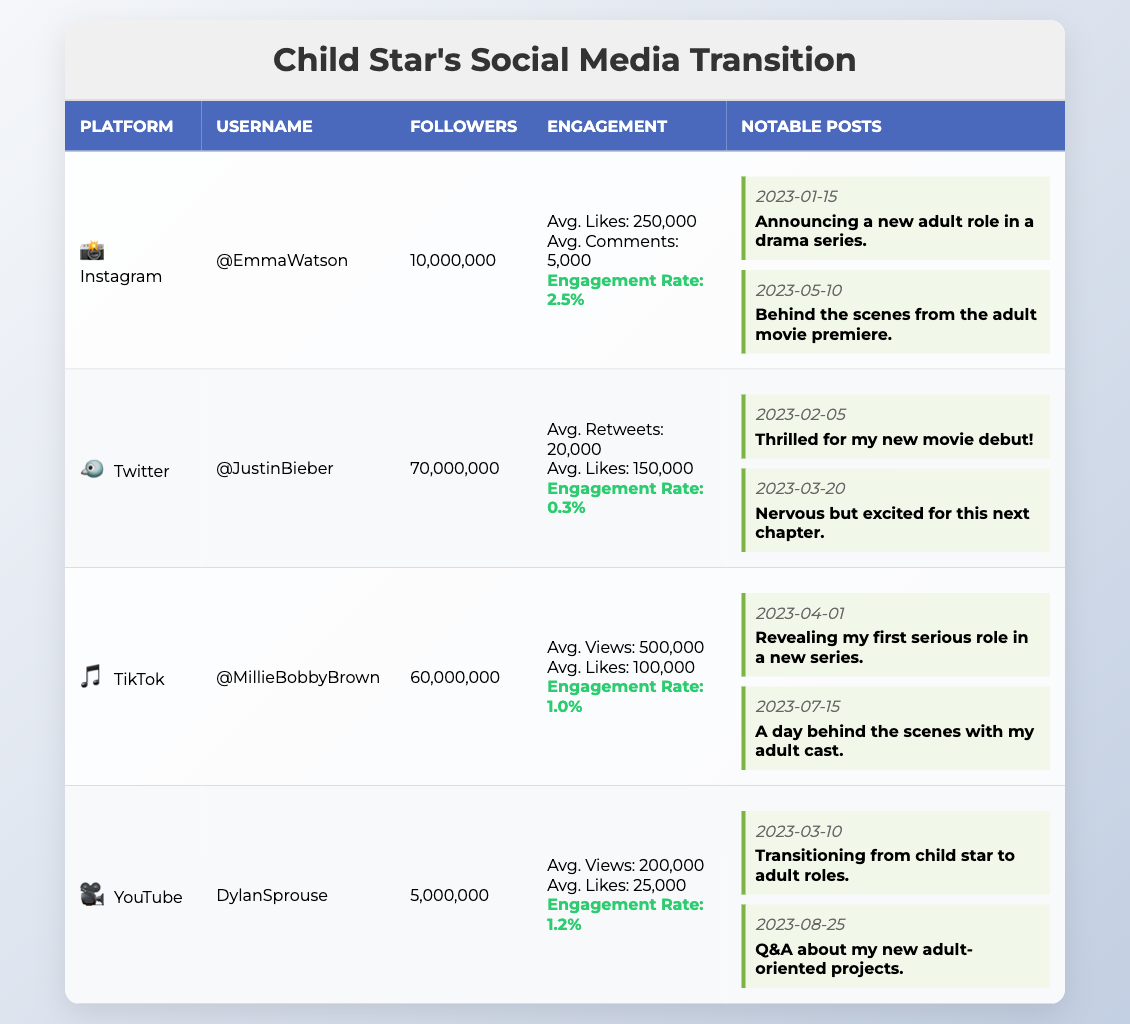What is the username of the celebrity with the highest number of followers? By comparing the followers of all the listed celebrities in the table, "@JustinBieber" has 70,000,000 followers, which is more than the others.
Answer: @JustinBieber Which platform has the highest engagement rate? The engagement rates for the platforms are: Instagram (2.5%), Twitter (0.3%), TikTok (1.0%), and YouTube (1.2%). The highest is Instagram at 2.5%.
Answer: Instagram What is the total number of notable posts listed for TikTok and YouTube combined? TikTok has 2 notable videos and YouTube has 2 notable videos, adding them gives 2 + 2 = 4.
Answer: 4 What were the likes on the notable post from Instagram dated 2023-01-15? The notable post on Instagram from that date had 300,000 likes as stated in the details.
Answer: 300,000 Is the engagement rate for YouTube higher than for TikTok? YouTube has an engagement rate of 1.2% and TikTok has 1.0%. Thus, 1.2% is higher than 1.0%.
Answer: Yes What is the difference in average likes between TikTok and Instagram? The average likes for TikTok is 100,000 and for Instagram, it is 250,000. The difference is 250,000 - 100,000 = 150,000.
Answer: 150,000 How many average views does Twitter receive per tweet? The table doesn’t provide average views for Twitter, but it does show average likes (150,000) and average retweets (20,000). The average views metric is not available.
Answer: N/A Which notable tweet from Twitter received the most likes? The notable tweet on 2023-02-05 had 200,000 likes, while the tweet on 2023-03-20 had 180,000 likes. The former received the most.
Answer: 200,000 From which platform did the celebrity announce their new adult role in a drama series? The announcement was made in a notable post on Instagram dated 2023-01-15.
Answer: Instagram What is the average engagement rate for the four platforms listed? The average engagement rate is calculated as (2.5% + 0.3% + 1.0% + 1.2%)/4 = 1.25%.
Answer: 1.25% 